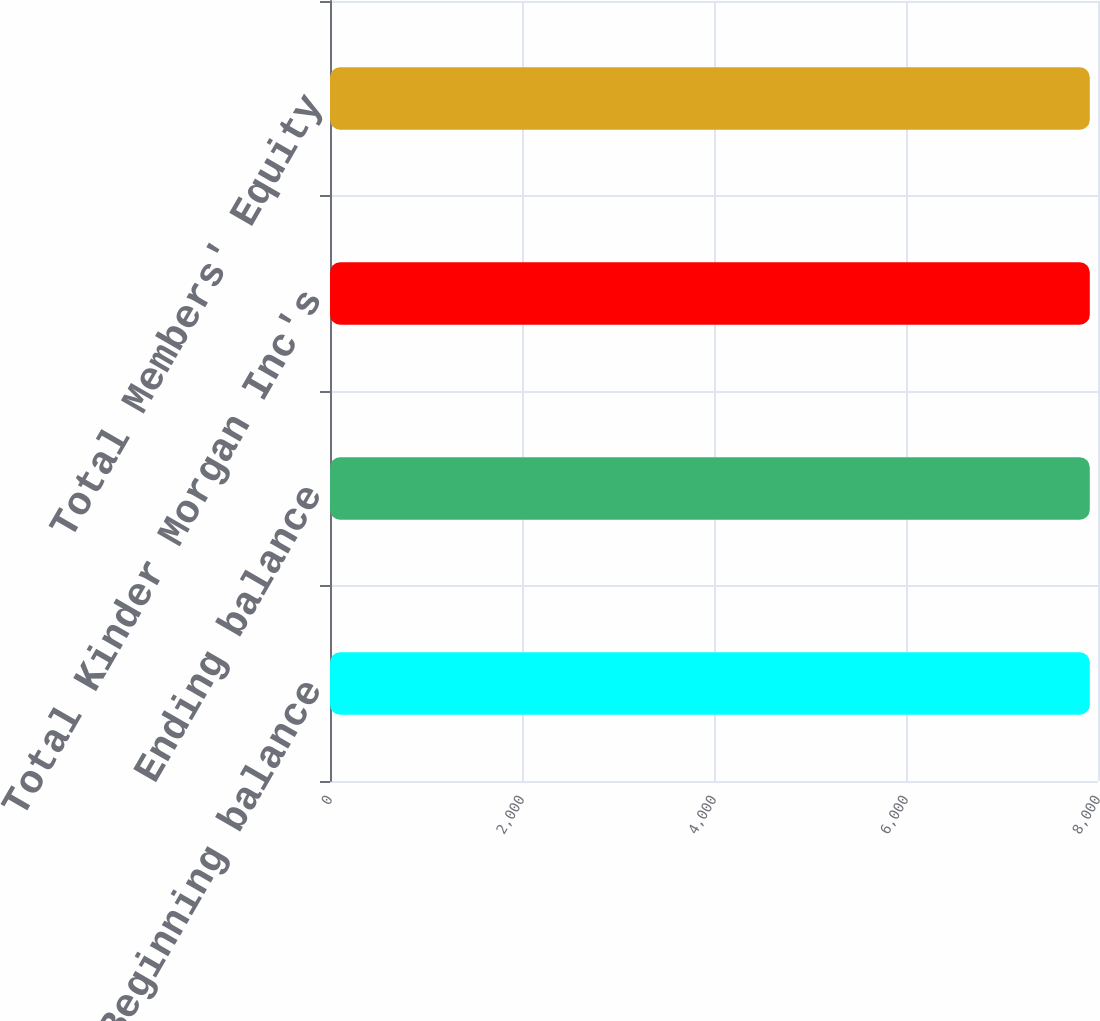<chart> <loc_0><loc_0><loc_500><loc_500><bar_chart><fcel>Beginning balance<fcel>Ending balance<fcel>Total Kinder Morgan Inc's<fcel>Total Members' Equity<nl><fcel>7914.4<fcel>7914.5<fcel>7914.6<fcel>7914.7<nl></chart> 